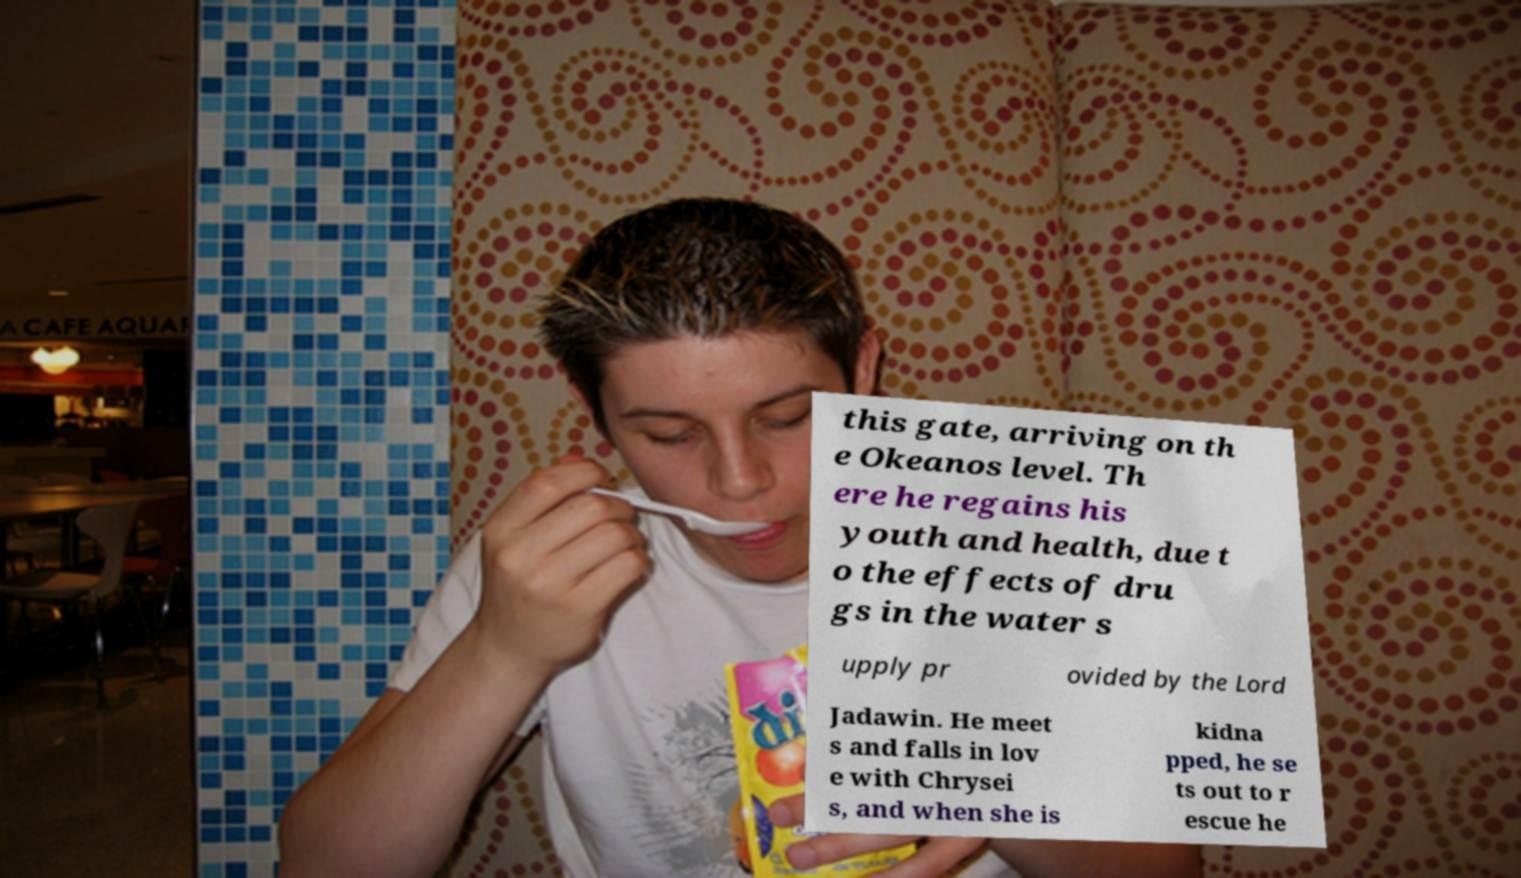Could you extract and type out the text from this image? this gate, arriving on th e Okeanos level. Th ere he regains his youth and health, due t o the effects of dru gs in the water s upply pr ovided by the Lord Jadawin. He meet s and falls in lov e with Chrysei s, and when she is kidna pped, he se ts out to r escue he 